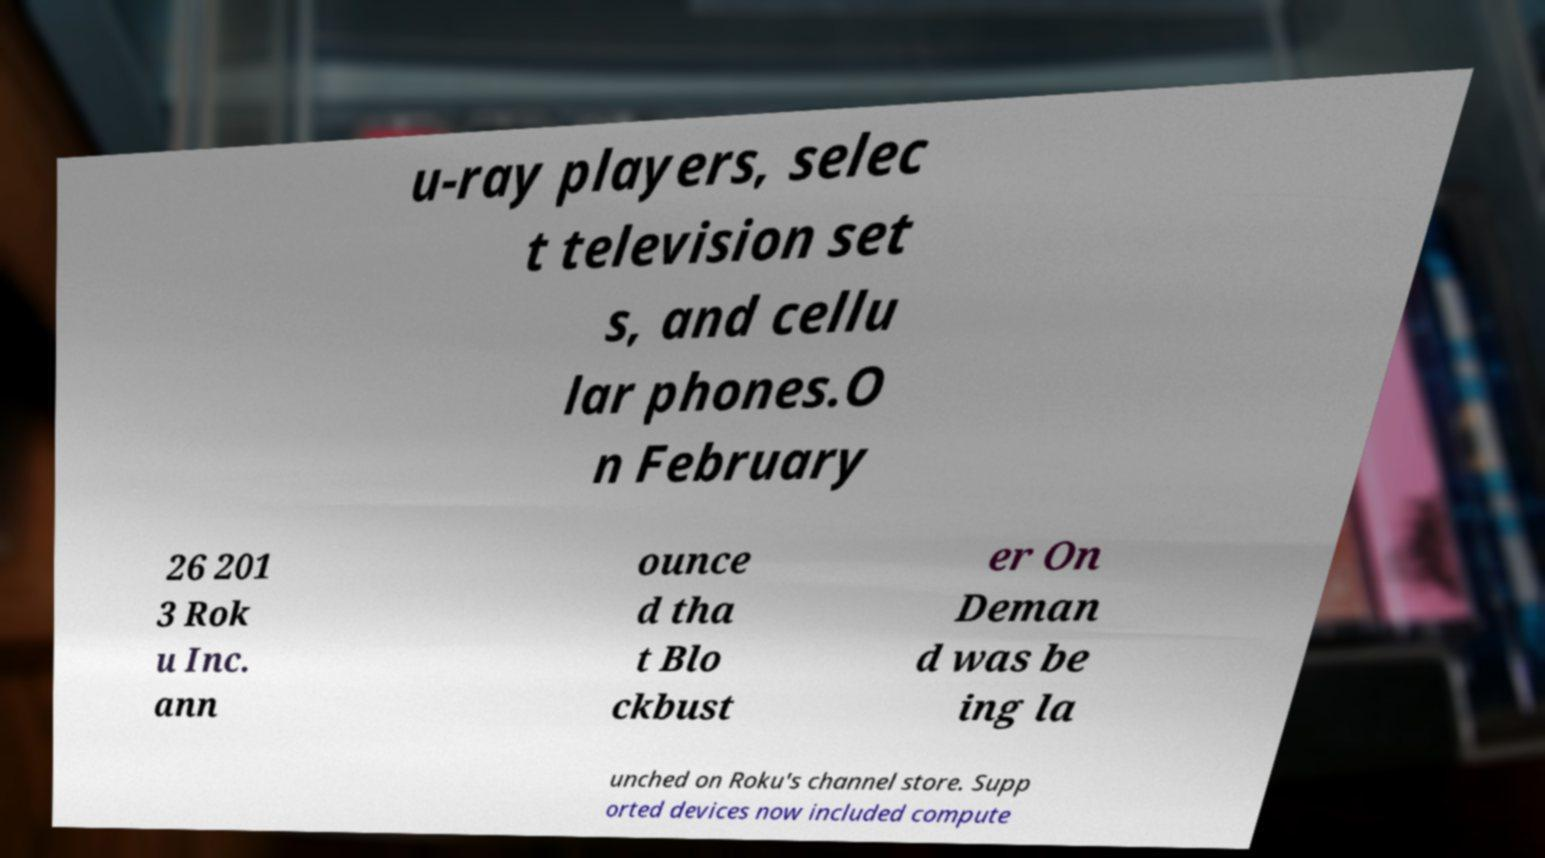Could you extract and type out the text from this image? u-ray players, selec t television set s, and cellu lar phones.O n February 26 201 3 Rok u Inc. ann ounce d tha t Blo ckbust er On Deman d was be ing la unched on Roku's channel store. Supp orted devices now included compute 